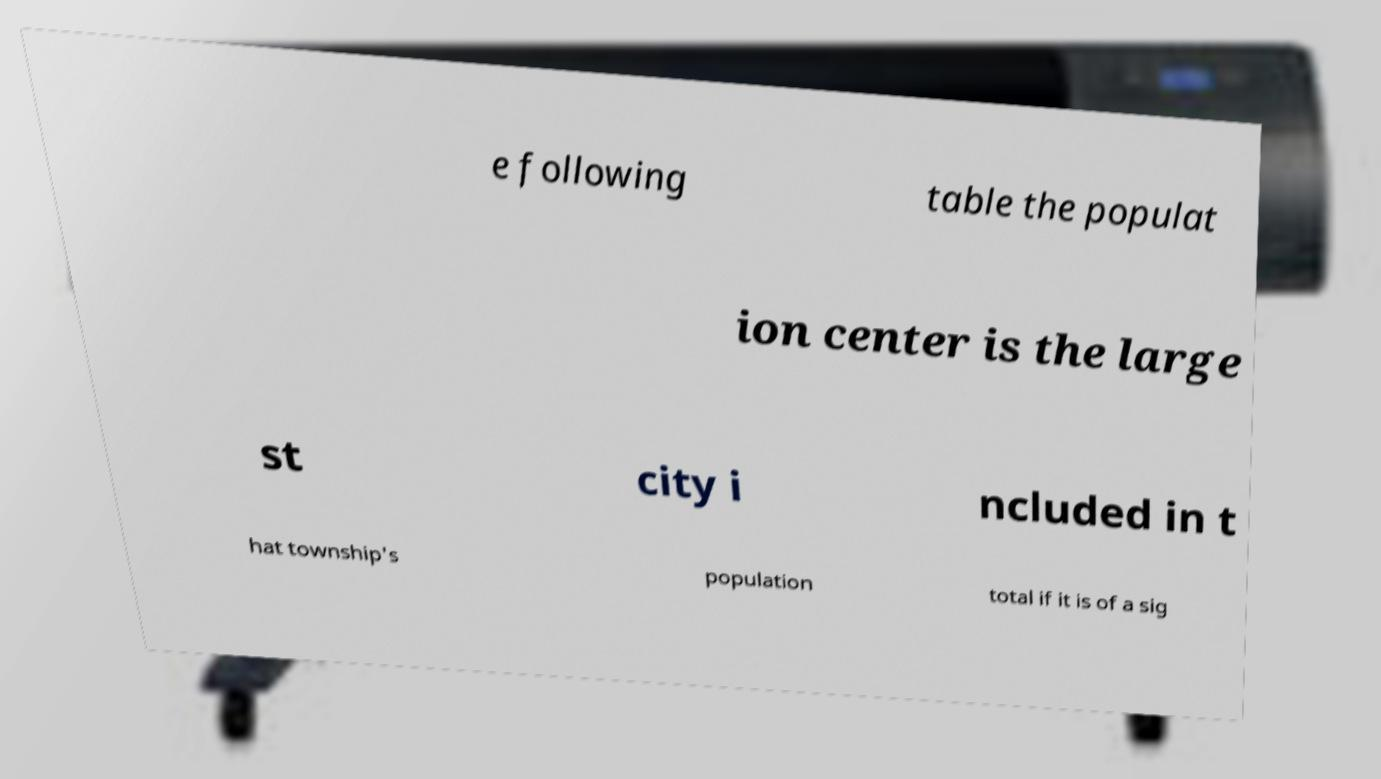Please read and relay the text visible in this image. What does it say? e following table the populat ion center is the large st city i ncluded in t hat township's population total if it is of a sig 